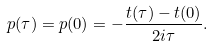Convert formula to latex. <formula><loc_0><loc_0><loc_500><loc_500>p ( \tau ) = p ( 0 ) = - \frac { t ( \tau ) - t ( 0 ) } { 2 i \tau } .</formula> 